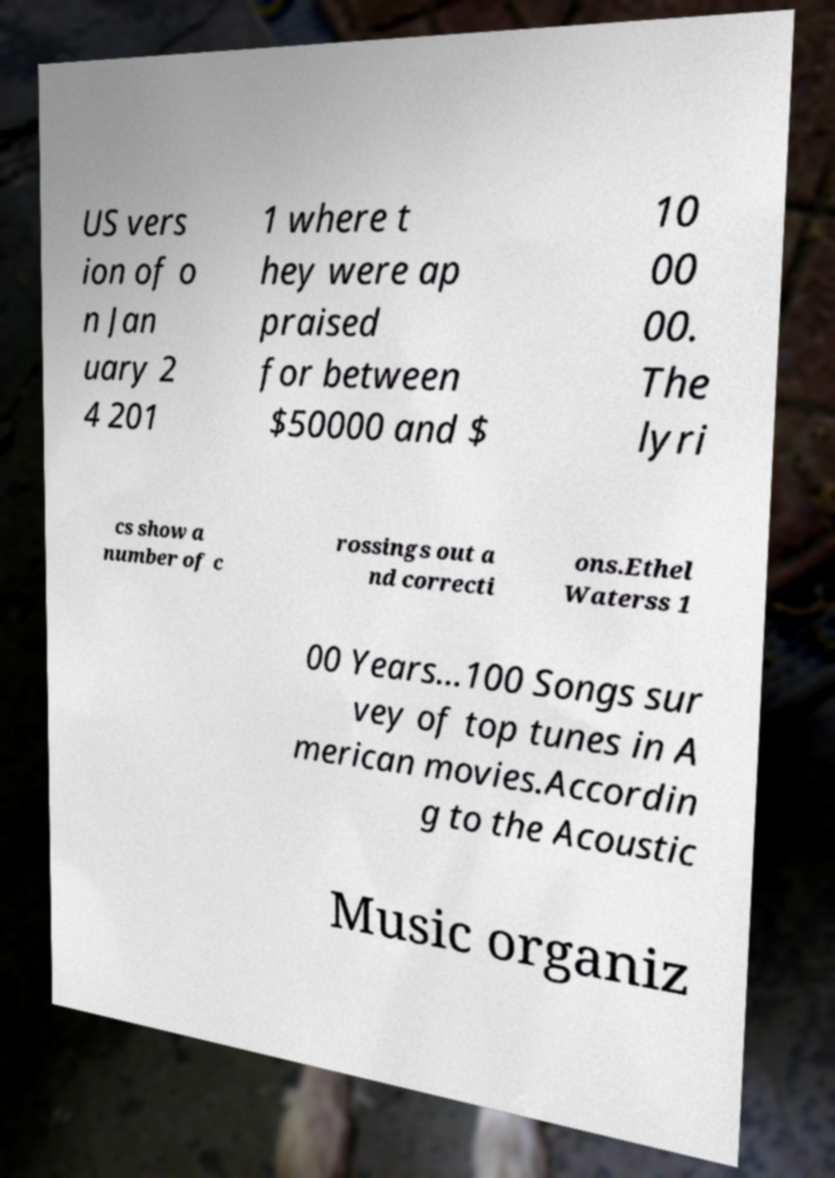What messages or text are displayed in this image? I need them in a readable, typed format. US vers ion of o n Jan uary 2 4 201 1 where t hey were ap praised for between $50000 and $ 10 00 00. The lyri cs show a number of c rossings out a nd correcti ons.Ethel Waterss 1 00 Years...100 Songs sur vey of top tunes in A merican movies.Accordin g to the Acoustic Music organiz 